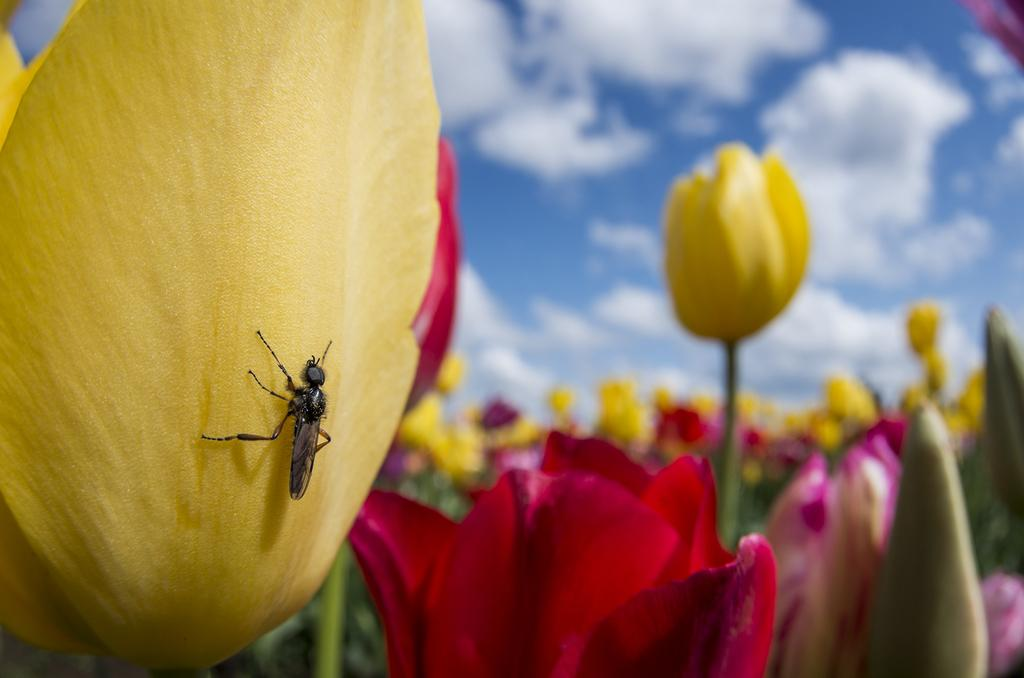What is the main subject of the image? There is a bug on a yellow flower in the image. What type of flowers can be seen in the background? There are many yellow and red flowers in the background of the image. What is visible at the top of the image? The sky is visible at the top of the image. What can be observed in the sky? Clouds are present in the sky. What type of sheet is covering the school in the image? There is no sheet or school present in the image; it features a bug on a yellow flower with yellow and red flowers in the background and clouds in the sky. 